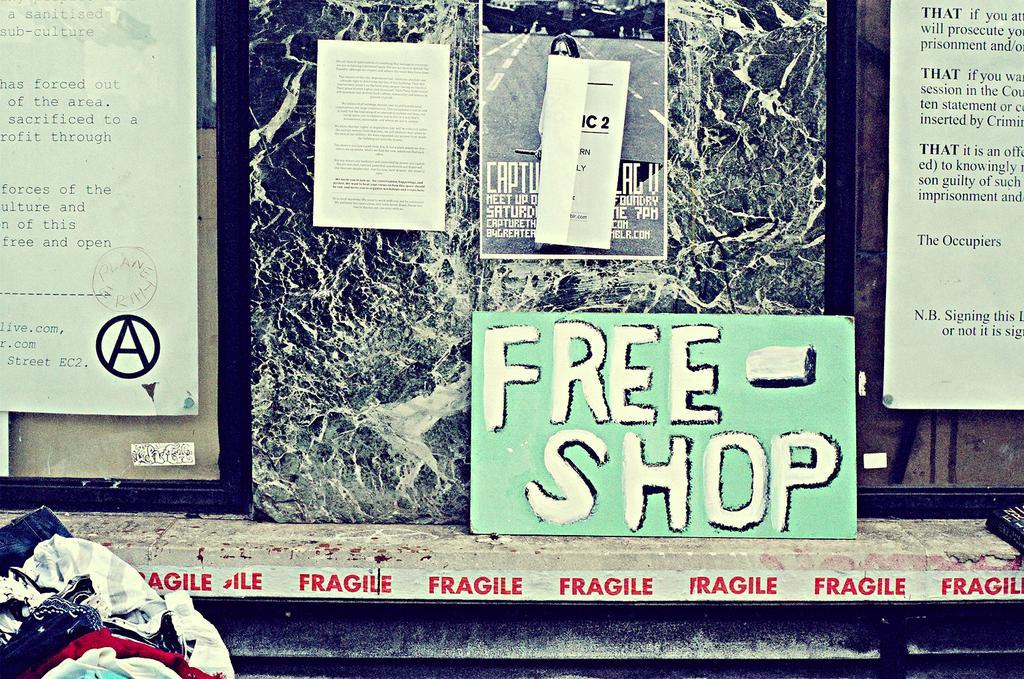How would you summarize this image in a sentence or two? In this image, in the left corner, we can see some clothes. In the background, we can see a table. On the table, we can see a board, on the board, we can see some text written on it. In the background, we can also see some pictures which are attached to a glass window. On the posters, we can see pictures and text written on it, at the bottom, we can see black color. 